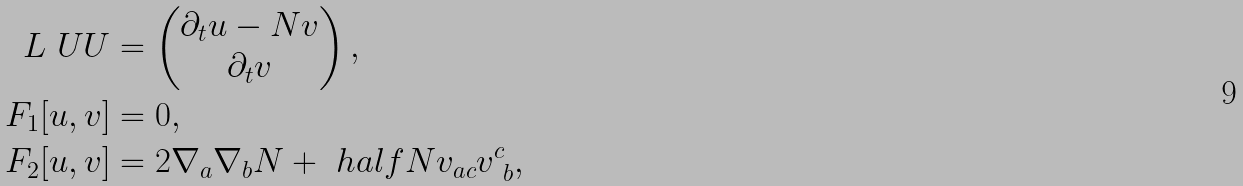<formula> <loc_0><loc_0><loc_500><loc_500>L \ U U & = \begin{pmatrix} \partial _ { t } u - N v \\ \partial _ { t } v \end{pmatrix} , \\ F _ { 1 } [ u , v ] & = 0 , \\ F _ { 2 } [ u , v ] & = 2 \nabla _ { a } \nabla _ { b } N + \ h a l f N v _ { a c } v ^ { c } _ { \ b } ,</formula> 